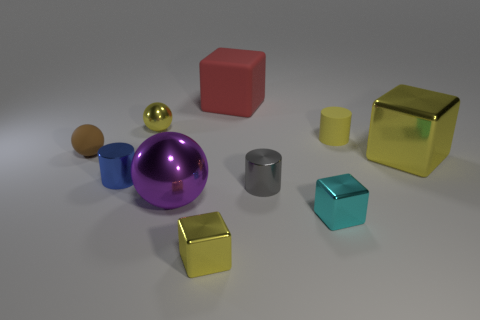Is the number of yellow things in front of the blue cylinder greater than the number of cyan metal things that are behind the large purple metallic sphere?
Your answer should be compact. Yes. How many tiny cylinders have the same material as the red cube?
Offer a terse response. 1. There is a small yellow shiny object that is on the right side of the tiny yellow sphere; is it the same shape as the thing that is left of the small blue cylinder?
Your response must be concise. No. There is a block that is behind the yellow rubber cylinder; what color is it?
Ensure brevity in your answer.  Red. Is there a blue thing of the same shape as the purple thing?
Give a very brief answer. No. What is the material of the tiny gray cylinder?
Provide a succinct answer. Metal. What is the size of the yellow thing that is on the left side of the tiny cyan thing and behind the large ball?
Your answer should be very brief. Small. What material is the small sphere that is the same color as the tiny matte cylinder?
Offer a terse response. Metal. How many small brown things are there?
Your answer should be compact. 1. Is the number of gray cylinders less than the number of spheres?
Your response must be concise. Yes. 